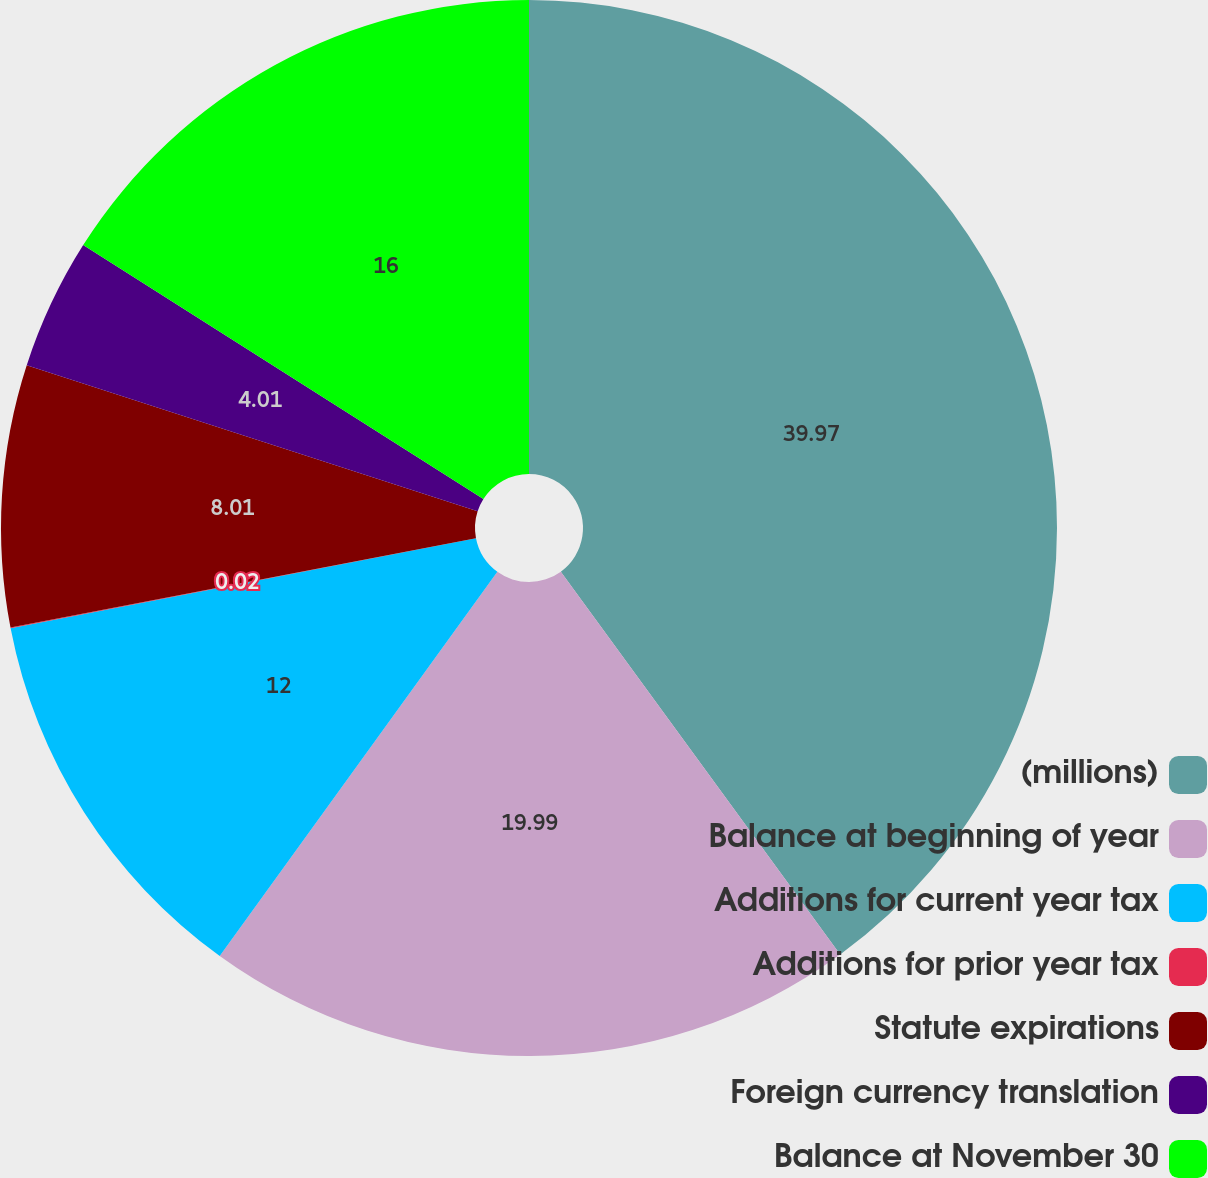Convert chart. <chart><loc_0><loc_0><loc_500><loc_500><pie_chart><fcel>(millions)<fcel>Balance at beginning of year<fcel>Additions for current year tax<fcel>Additions for prior year tax<fcel>Statute expirations<fcel>Foreign currency translation<fcel>Balance at November 30<nl><fcel>39.97%<fcel>19.99%<fcel>12.0%<fcel>0.02%<fcel>8.01%<fcel>4.01%<fcel>16.0%<nl></chart> 